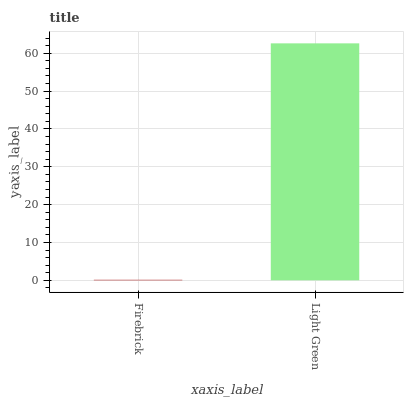Is Light Green the minimum?
Answer yes or no. No. Is Light Green greater than Firebrick?
Answer yes or no. Yes. Is Firebrick less than Light Green?
Answer yes or no. Yes. Is Firebrick greater than Light Green?
Answer yes or no. No. Is Light Green less than Firebrick?
Answer yes or no. No. Is Light Green the high median?
Answer yes or no. Yes. Is Firebrick the low median?
Answer yes or no. Yes. Is Firebrick the high median?
Answer yes or no. No. Is Light Green the low median?
Answer yes or no. No. 